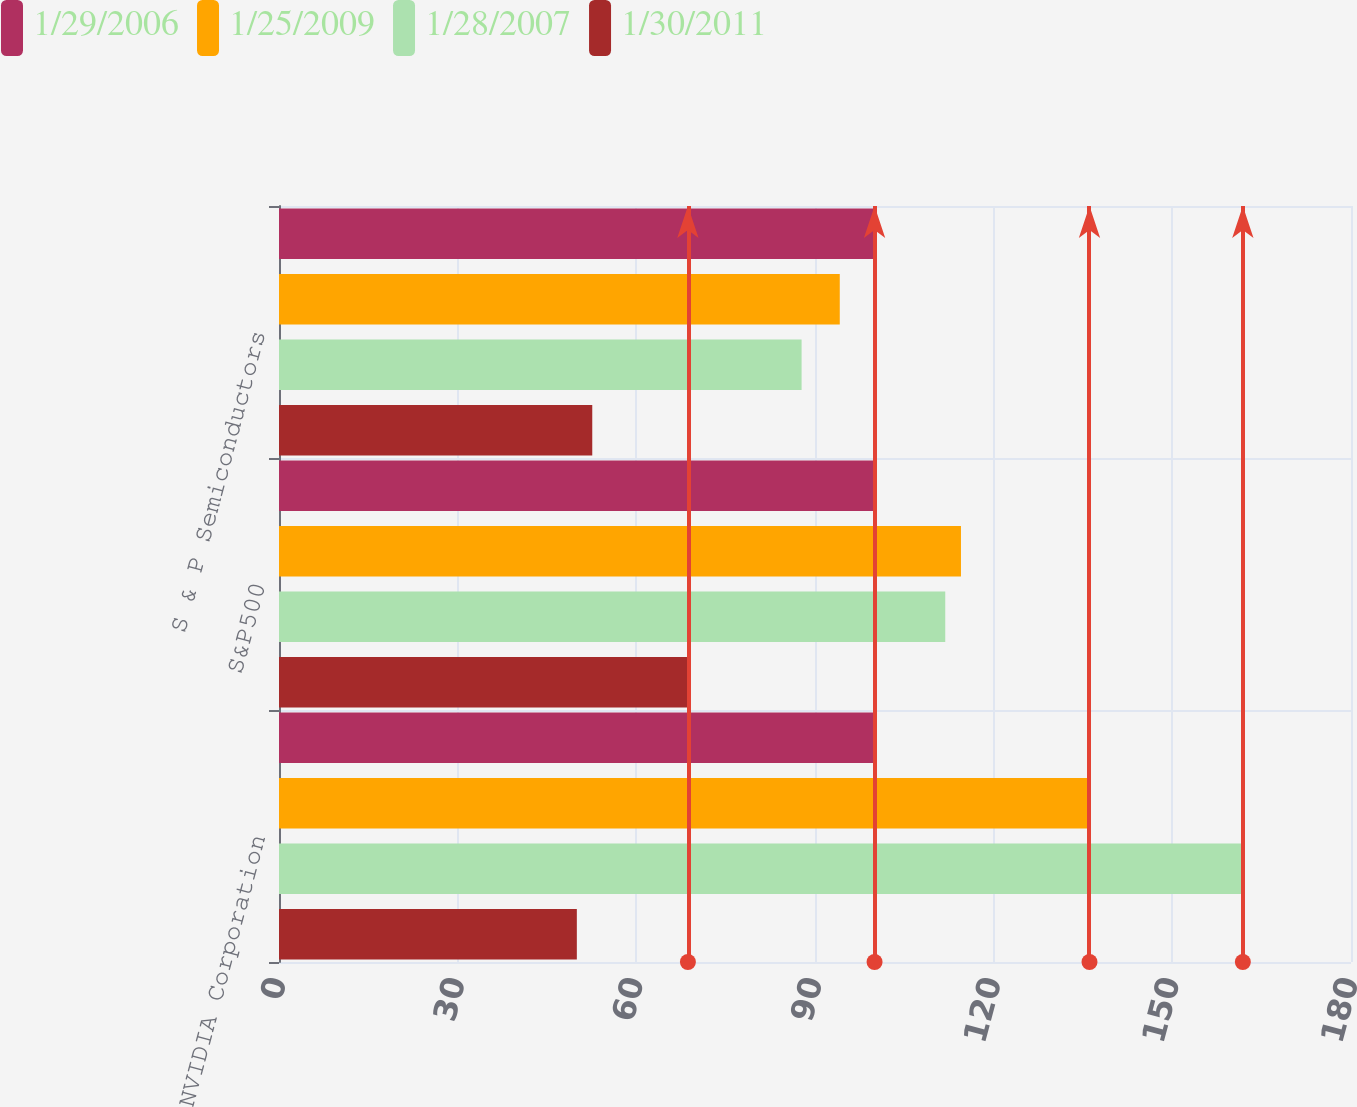<chart> <loc_0><loc_0><loc_500><loc_500><stacked_bar_chart><ecel><fcel>NVIDIA Corporation<fcel>S&P500<fcel>S & P Semiconductors<nl><fcel>1/29/2006<fcel>100<fcel>100<fcel>100<nl><fcel>1/25/2009<fcel>136.09<fcel>114.51<fcel>94.16<nl><fcel>1/28/2007<fcel>161.84<fcel>111.87<fcel>87.75<nl><fcel>1/30/2011<fcel>50.01<fcel>68.66<fcel>52.6<nl></chart> 